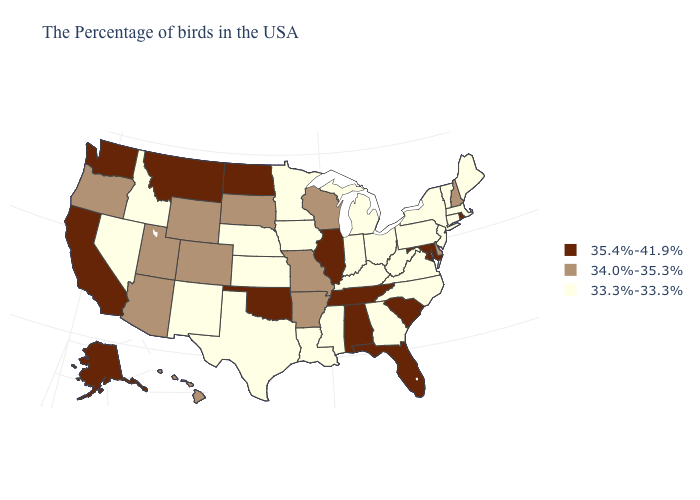Does Indiana have the highest value in the USA?
Give a very brief answer. No. Is the legend a continuous bar?
Be succinct. No. What is the value of Indiana?
Write a very short answer. 33.3%-33.3%. Name the states that have a value in the range 34.0%-35.3%?
Quick response, please. New Hampshire, Delaware, Wisconsin, Missouri, Arkansas, South Dakota, Wyoming, Colorado, Utah, Arizona, Oregon, Hawaii. Name the states that have a value in the range 34.0%-35.3%?
Concise answer only. New Hampshire, Delaware, Wisconsin, Missouri, Arkansas, South Dakota, Wyoming, Colorado, Utah, Arizona, Oregon, Hawaii. What is the value of New York?
Concise answer only. 33.3%-33.3%. Which states hav the highest value in the MidWest?
Give a very brief answer. Illinois, North Dakota. Among the states that border South Dakota , which have the lowest value?
Write a very short answer. Minnesota, Iowa, Nebraska. What is the value of Colorado?
Be succinct. 34.0%-35.3%. What is the highest value in the Northeast ?
Give a very brief answer. 35.4%-41.9%. What is the highest value in states that border Minnesota?
Concise answer only. 35.4%-41.9%. Among the states that border Indiana , which have the lowest value?
Give a very brief answer. Ohio, Michigan, Kentucky. What is the value of Utah?
Be succinct. 34.0%-35.3%. Is the legend a continuous bar?
Write a very short answer. No. What is the highest value in states that border Missouri?
Keep it brief. 35.4%-41.9%. 